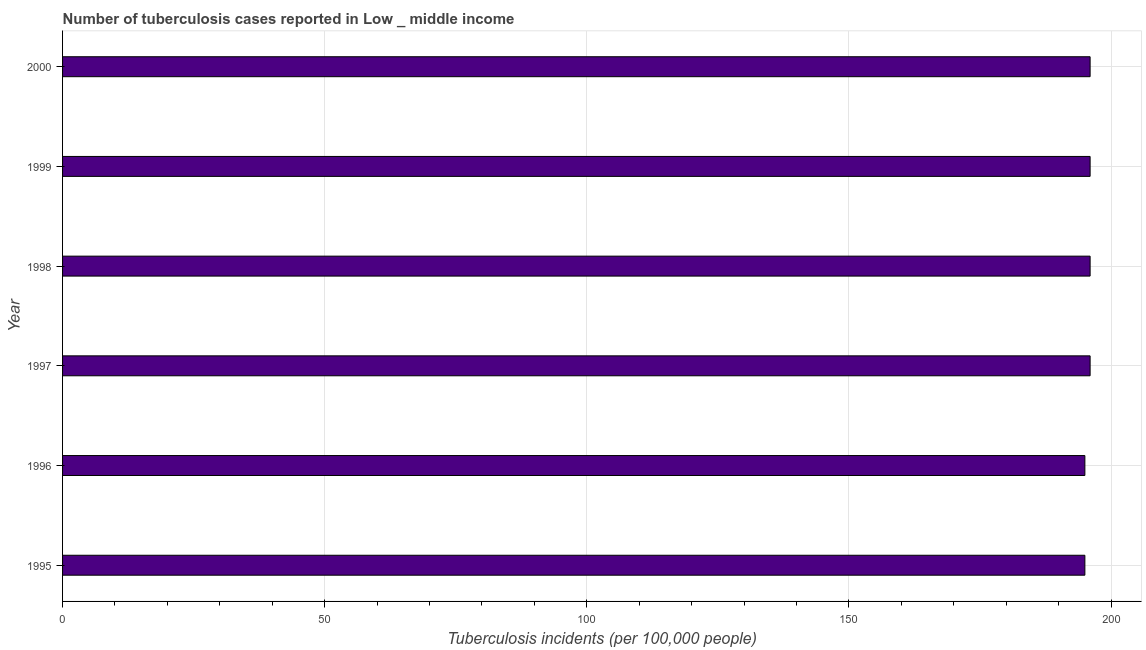Does the graph contain any zero values?
Your response must be concise. No. Does the graph contain grids?
Ensure brevity in your answer.  Yes. What is the title of the graph?
Offer a terse response. Number of tuberculosis cases reported in Low _ middle income. What is the label or title of the X-axis?
Make the answer very short. Tuberculosis incidents (per 100,0 people). What is the label or title of the Y-axis?
Offer a very short reply. Year. What is the number of tuberculosis incidents in 1997?
Ensure brevity in your answer.  196. Across all years, what is the maximum number of tuberculosis incidents?
Ensure brevity in your answer.  196. Across all years, what is the minimum number of tuberculosis incidents?
Your answer should be very brief. 195. In which year was the number of tuberculosis incidents minimum?
Your answer should be compact. 1995. What is the sum of the number of tuberculosis incidents?
Keep it short and to the point. 1174. What is the average number of tuberculosis incidents per year?
Your answer should be compact. 195. What is the median number of tuberculosis incidents?
Your answer should be compact. 196. What is the ratio of the number of tuberculosis incidents in 1997 to that in 2000?
Offer a terse response. 1. What is the difference between the highest and the second highest number of tuberculosis incidents?
Keep it short and to the point. 0. Is the sum of the number of tuberculosis incidents in 1997 and 1998 greater than the maximum number of tuberculosis incidents across all years?
Your answer should be very brief. Yes. In how many years, is the number of tuberculosis incidents greater than the average number of tuberculosis incidents taken over all years?
Provide a short and direct response. 4. How many bars are there?
Offer a terse response. 6. Are all the bars in the graph horizontal?
Offer a very short reply. Yes. What is the difference between two consecutive major ticks on the X-axis?
Ensure brevity in your answer.  50. What is the Tuberculosis incidents (per 100,000 people) in 1995?
Your response must be concise. 195. What is the Tuberculosis incidents (per 100,000 people) of 1996?
Your response must be concise. 195. What is the Tuberculosis incidents (per 100,000 people) of 1997?
Give a very brief answer. 196. What is the Tuberculosis incidents (per 100,000 people) in 1998?
Ensure brevity in your answer.  196. What is the Tuberculosis incidents (per 100,000 people) of 1999?
Your answer should be very brief. 196. What is the Tuberculosis incidents (per 100,000 people) in 2000?
Provide a succinct answer. 196. What is the difference between the Tuberculosis incidents (per 100,000 people) in 1995 and 1996?
Offer a terse response. 0. What is the difference between the Tuberculosis incidents (per 100,000 people) in 1995 and 1999?
Keep it short and to the point. -1. What is the difference between the Tuberculosis incidents (per 100,000 people) in 1996 and 1997?
Your answer should be compact. -1. What is the difference between the Tuberculosis incidents (per 100,000 people) in 1996 and 1999?
Your answer should be very brief. -1. What is the difference between the Tuberculosis incidents (per 100,000 people) in 1996 and 2000?
Your answer should be very brief. -1. What is the difference between the Tuberculosis incidents (per 100,000 people) in 1998 and 1999?
Provide a succinct answer. 0. What is the difference between the Tuberculosis incidents (per 100,000 people) in 1998 and 2000?
Your response must be concise. 0. What is the ratio of the Tuberculosis incidents (per 100,000 people) in 1995 to that in 2000?
Your answer should be very brief. 0.99. What is the ratio of the Tuberculosis incidents (per 100,000 people) in 1996 to that in 1998?
Give a very brief answer. 0.99. What is the ratio of the Tuberculosis incidents (per 100,000 people) in 1996 to that in 1999?
Offer a very short reply. 0.99. What is the ratio of the Tuberculosis incidents (per 100,000 people) in 1997 to that in 1998?
Give a very brief answer. 1. What is the ratio of the Tuberculosis incidents (per 100,000 people) in 1997 to that in 1999?
Offer a very short reply. 1. What is the ratio of the Tuberculosis incidents (per 100,000 people) in 1999 to that in 2000?
Ensure brevity in your answer.  1. 